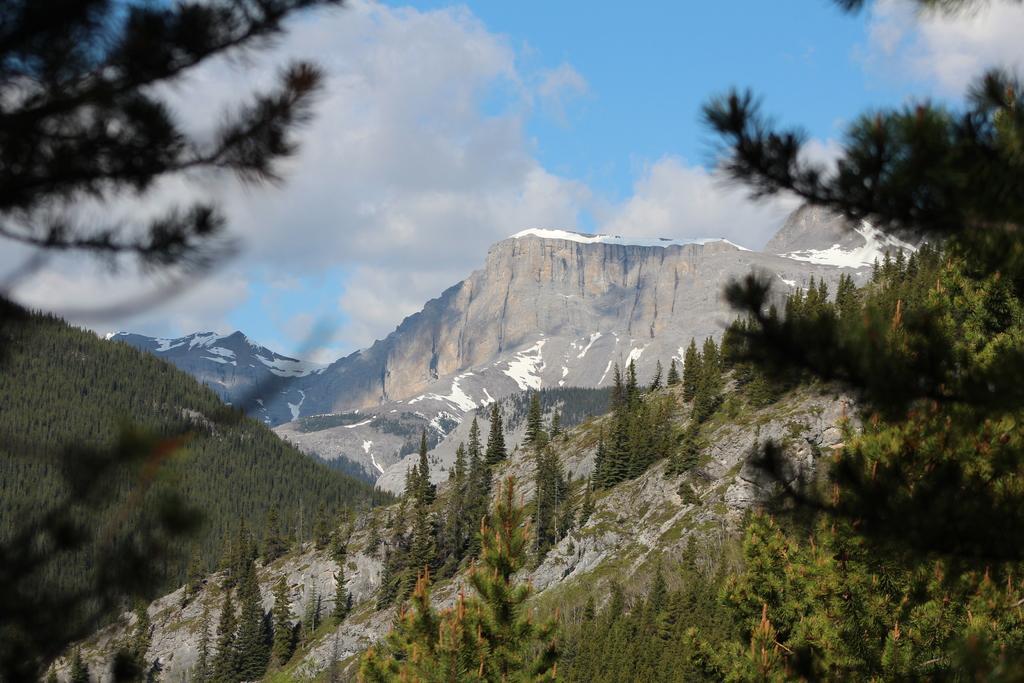Could you give a brief overview of what you see in this image? In this image we can see sky with clouds, mountains, trees and hills. 